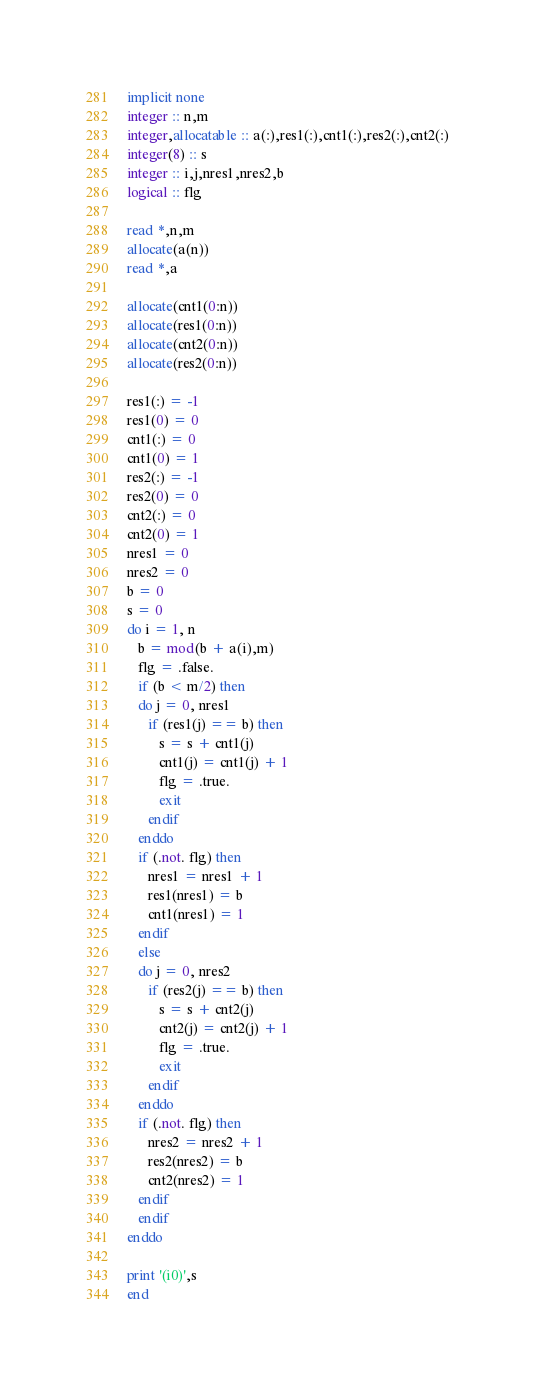Convert code to text. <code><loc_0><loc_0><loc_500><loc_500><_FORTRAN_>implicit none
integer :: n,m
integer,allocatable :: a(:),res1(:),cnt1(:),res2(:),cnt2(:)
integer(8) :: s
integer :: i,j,nres1,nres2,b
logical :: flg

read *,n,m
allocate(a(n))
read *,a

allocate(cnt1(0:n))
allocate(res1(0:n))
allocate(cnt2(0:n))
allocate(res2(0:n))

res1(:) = -1
res1(0) = 0
cnt1(:) = 0
cnt1(0) = 1
res2(:) = -1
res2(0) = 0
cnt2(:) = 0
cnt2(0) = 1
nres1 = 0
nres2 = 0
b = 0
s = 0
do i = 1, n
   b = mod(b + a(i),m)
   flg = .false.
   if (b < m/2) then
   do j = 0, nres1
      if (res1(j) == b) then
         s = s + cnt1(j)
         cnt1(j) = cnt1(j) + 1
         flg = .true.
         exit
      endif
   enddo
   if (.not. flg) then
      nres1 = nres1 + 1
      res1(nres1) = b
      cnt1(nres1) = 1
   endif
   else
   do j = 0, nres2
      if (res2(j) == b) then
         s = s + cnt2(j)
         cnt2(j) = cnt2(j) + 1
         flg = .true.
         exit
      endif
   enddo
   if (.not. flg) then
      nres2 = nres2 + 1
      res2(nres2) = b
      cnt2(nres2) = 1
   endif
   endif
enddo

print '(i0)',s
end</code> 